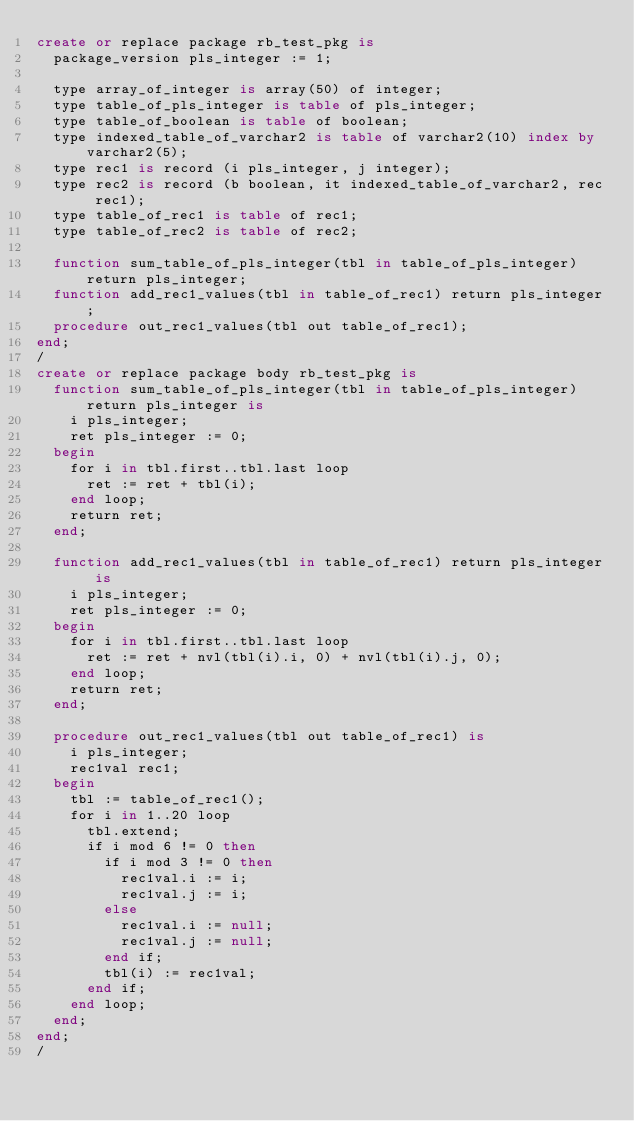Convert code to text. <code><loc_0><loc_0><loc_500><loc_500><_SQL_>create or replace package rb_test_pkg is
  package_version pls_integer := 1;

  type array_of_integer is array(50) of integer;
  type table_of_pls_integer is table of pls_integer;
  type table_of_boolean is table of boolean;
  type indexed_table_of_varchar2 is table of varchar2(10) index by varchar2(5);
  type rec1 is record (i pls_integer, j integer);
  type rec2 is record (b boolean, it indexed_table_of_varchar2, rec rec1);
  type table_of_rec1 is table of rec1;
  type table_of_rec2 is table of rec2;

  function sum_table_of_pls_integer(tbl in table_of_pls_integer) return pls_integer;
  function add_rec1_values(tbl in table_of_rec1) return pls_integer;
  procedure out_rec1_values(tbl out table_of_rec1);
end;
/
create or replace package body rb_test_pkg is
  function sum_table_of_pls_integer(tbl in table_of_pls_integer) return pls_integer is
    i pls_integer;
    ret pls_integer := 0;
  begin
    for i in tbl.first..tbl.last loop
      ret := ret + tbl(i);
    end loop;
    return ret;
  end;

  function add_rec1_values(tbl in table_of_rec1) return pls_integer is
    i pls_integer;
    ret pls_integer := 0;
  begin
    for i in tbl.first..tbl.last loop
      ret := ret + nvl(tbl(i).i, 0) + nvl(tbl(i).j, 0);
    end loop;
    return ret;
  end;

  procedure out_rec1_values(tbl out table_of_rec1) is
    i pls_integer;
    rec1val rec1;
  begin
    tbl := table_of_rec1();
    for i in 1..20 loop
      tbl.extend;
      if i mod 6 != 0 then
        if i mod 3 != 0 then
          rec1val.i := i;
          rec1val.j := i;
        else
          rec1val.i := null;
          rec1val.j := null;
        end if;
        tbl(i) := rec1val;
      end if;
    end loop;
  end;
end;
/
</code> 